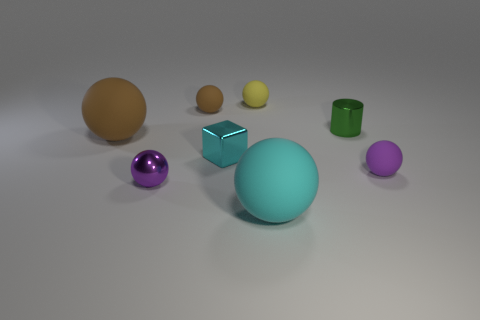Subtract 1 spheres. How many spheres are left? 5 Subtract all tiny yellow rubber balls. How many balls are left? 5 Subtract all brown spheres. How many spheres are left? 4 Subtract all red spheres. Subtract all brown cylinders. How many spheres are left? 6 Add 1 small green shiny cylinders. How many objects exist? 9 Subtract all cubes. How many objects are left? 7 Subtract 1 green cylinders. How many objects are left? 7 Subtract all tiny shiny cylinders. Subtract all small objects. How many objects are left? 1 Add 3 small matte spheres. How many small matte spheres are left? 6 Add 7 tiny brown rubber spheres. How many tiny brown rubber spheres exist? 8 